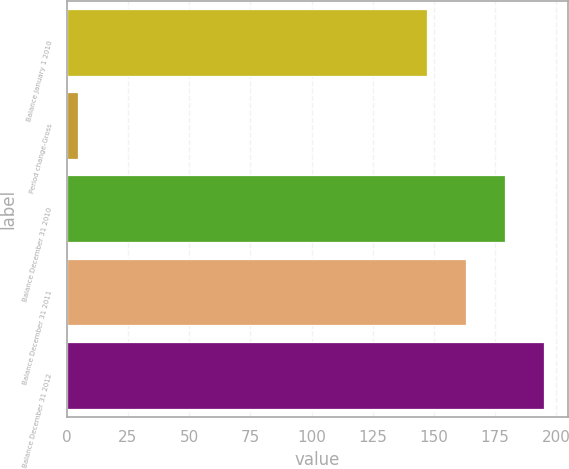Convert chart to OTSL. <chart><loc_0><loc_0><loc_500><loc_500><bar_chart><fcel>Balance January 1 2010<fcel>Period change-Gross<fcel>Balance December 31 2010<fcel>Balance December 31 2011<fcel>Balance December 31 2012<nl><fcel>147.2<fcel>4.5<fcel>179<fcel>163.1<fcel>194.9<nl></chart> 